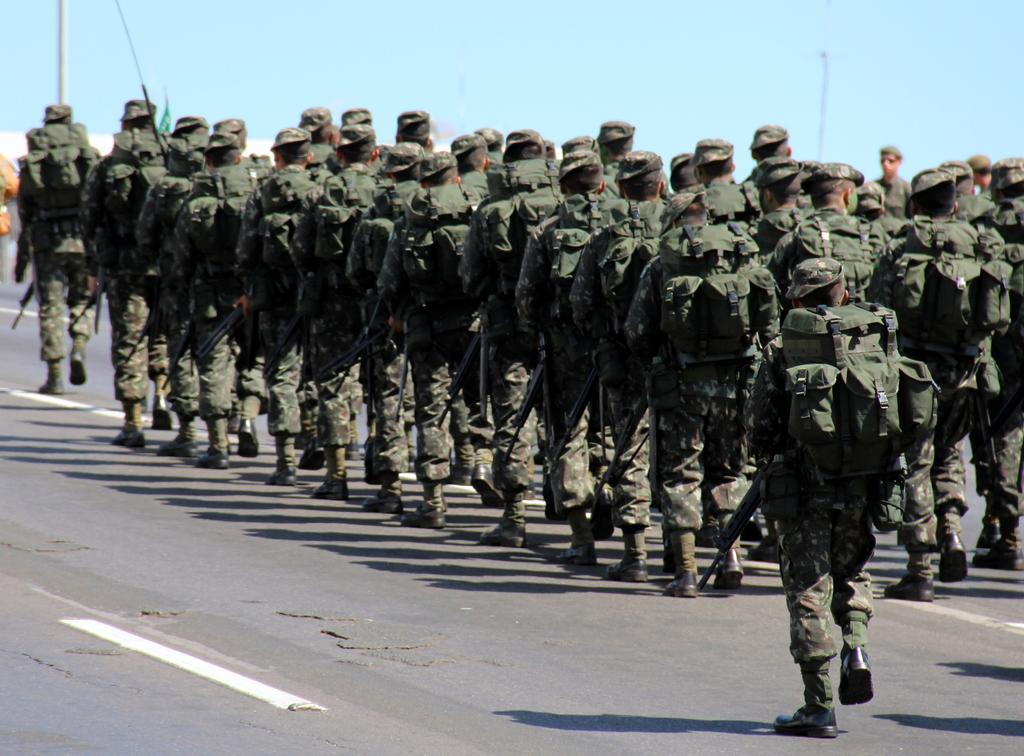What are the people in the image doing? There are soldiers walking in the image. What can be seen on the ground in the image? There is a road visible in the image. What objects are present in the image besides the soldiers and road? There are poles in the image. What is visible in the background of the image? The sky is visible in the image. Can you describe the dinosaurs walking alongside the soldiers in the image? There are no dinosaurs present in the image; it only features soldiers walking. 